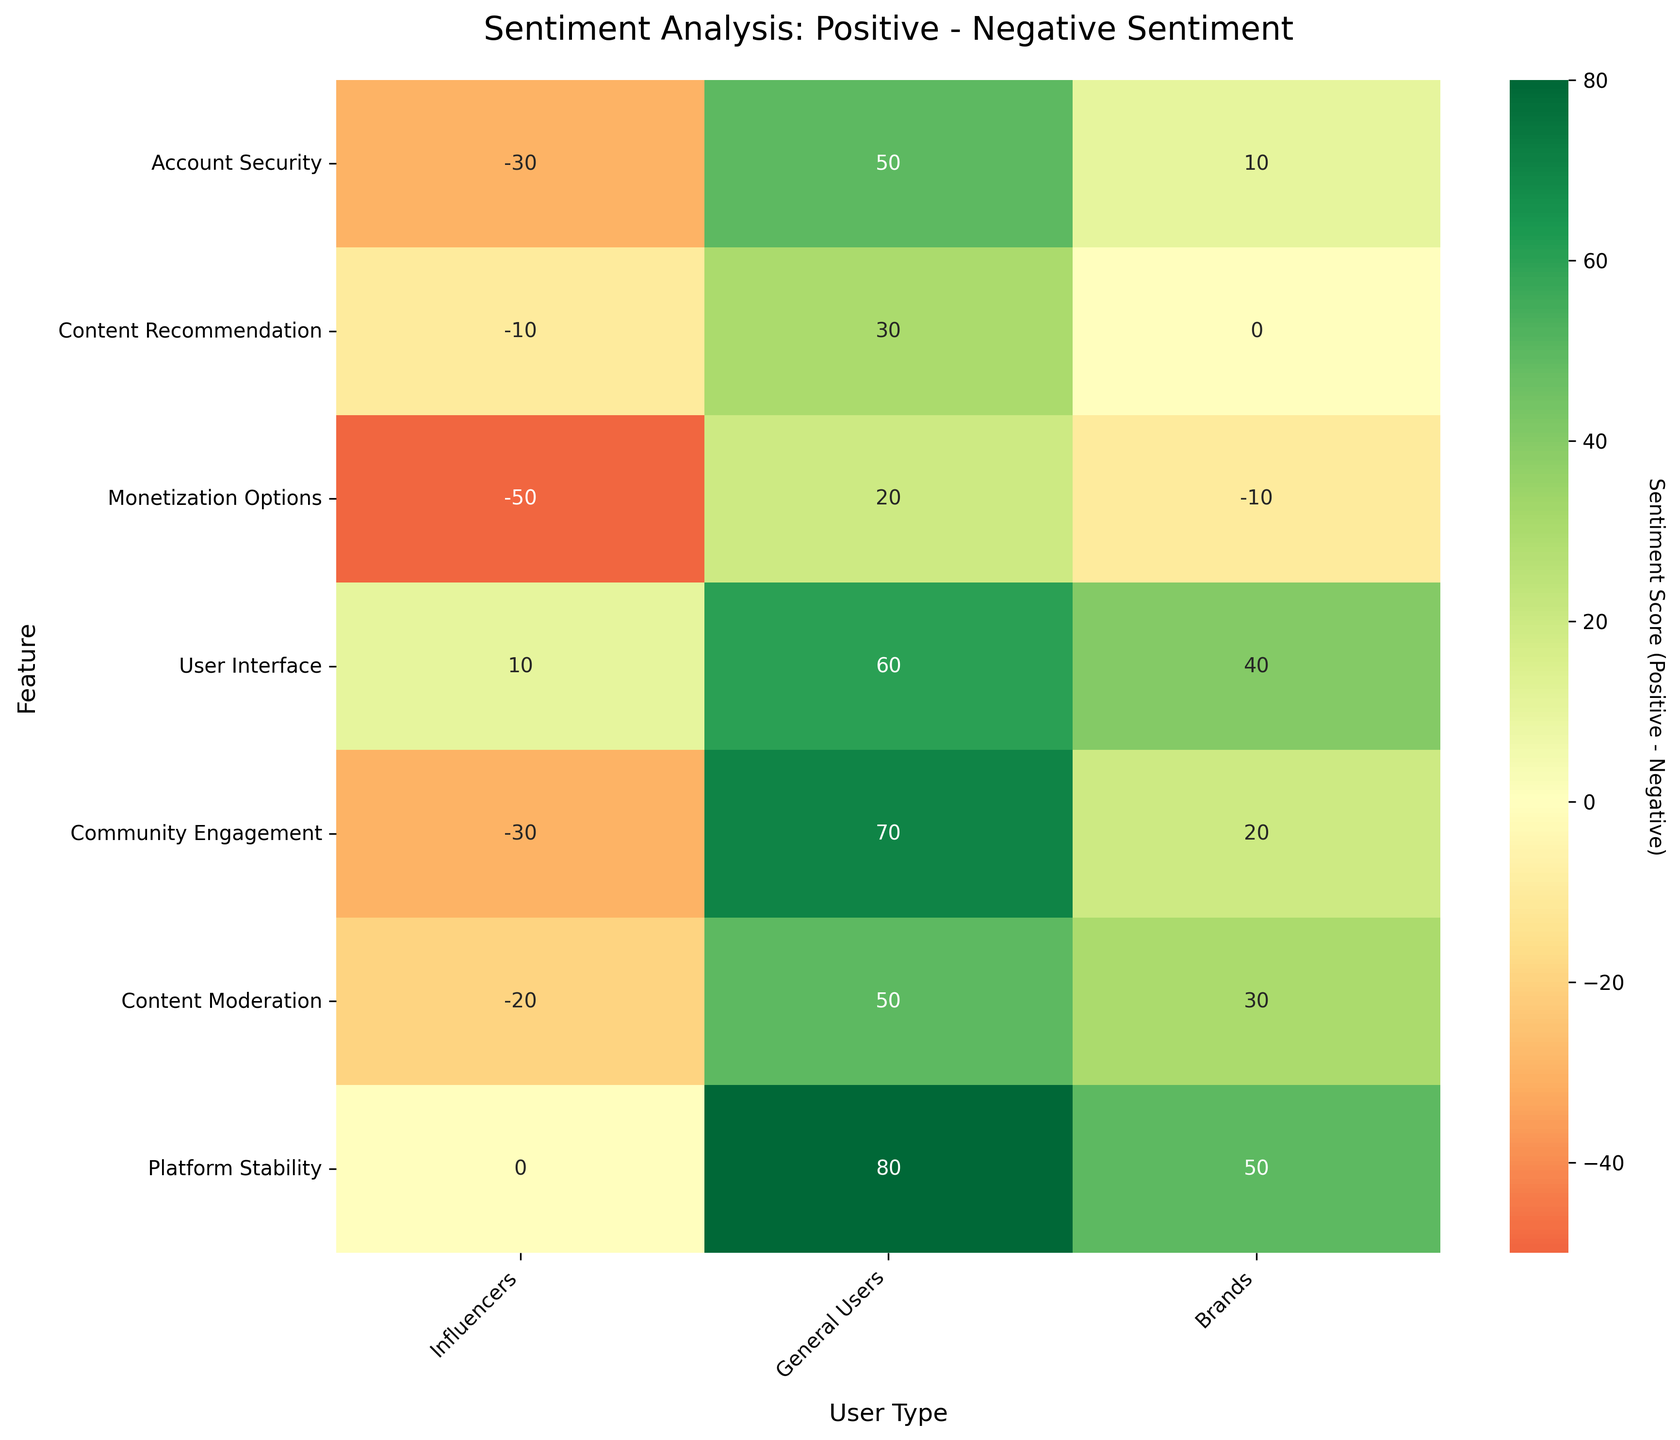What's the title of the heatmap? The title is written at the top of the figure, usually in larger font size for emphasis. It helps understand the focus of the heatmap.
Answer: Sentiment Analysis: Positive - Negative Sentiment What does the color green indicate on the heatmap? In this heatmap using a 'RdYlGn' color scheme, green shades typically represent positive sentiment scores, showing features that are viewed more positively.
Answer: Positive sentiment Which user type has the most negative sentiment towards Monetization Options? By looking at the color shading for Monetization Options across user types, the section that is darkest towards the red end will indicate the highest negative sentiment.
Answer: Influencers What user type has the highest positive sentiment score for Platform Stability? Find the section corresponding to Platform Stability in the heatmap and identify which user type has the brightest green shade, indicating the highest positive sentiment score.
Answer: General Users Between Content Moderation and User Interface, which feature do Influencers view more positively? Compare the shades of green to red for Influencers across Content Moderation and User Interface. The one greener in color has a more positive sentiment.
Answer: User Interface What's the difference in sentiment scores between Account Security for Influencers and General Users? Calculate the sentiment score (Positive - Negative) for both Influencers and General Users for Account Security and then take the difference: (30-60) and (70-20). So, -30 and 50. Then, 50 - -30 = 80.
Answer: 80 Which feature has the lowest sentiment score from Influencers? Look for the feature with the darkest red shade in the Influencer column, indicating the lowest sentiment score.
Answer: Monetization Options Rank the features from most to least positively perceived by General Users. Go through the General Users column, ranking the features based on the greenest to reddest shades: Platform Stability, Community Engagement, User Interface, Account Security, Content Moderation, Content Recommendation, Monetization Options.
Answer: Platform Stability, Community Engagement, User Interface, Account Security, Content Moderation, Content Recommendation, Monetization Options Which user type has the smallest range of sentiment scores across all features? Calculate the range (max score - min score) for each user type's sentiment across all features. The one with the smallest range will have the least distance between its highest and lowest values.
Answer: General Users Explain the sentiment score for Content Recommendation for Brands. The sentiment score is calculated as Positive Sentiment - Negative Sentiment. For Content Recommendation for Brands, it's 45 - 45. Therefore, the score is 0, indicating a neutral sentiment.
Answer: Neutral 